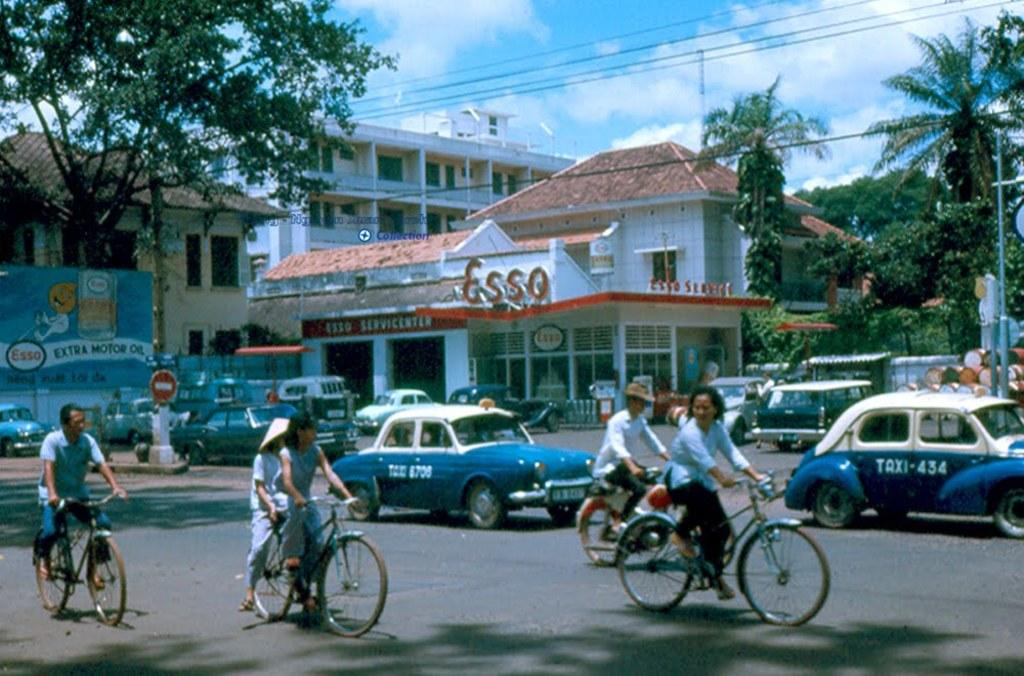What type of setting is depicted in the image? The image is an outdoor scene. What natural elements can be seen in the image? There are trees in the image. What man-made structures are present in the image? There are buildings with windows in the image. What mode of transportation can be seen on the road in the image? There are vehicles on the road in the image. What activity are some people engaged in within the image? There is a group of people riding bicycles in the image. What type of meat can be seen hanging from the trees in the image? There is no meat hanging from the trees in the image; it depicts an outdoor scene with trees, buildings, vehicles, and people riding bicycles. 